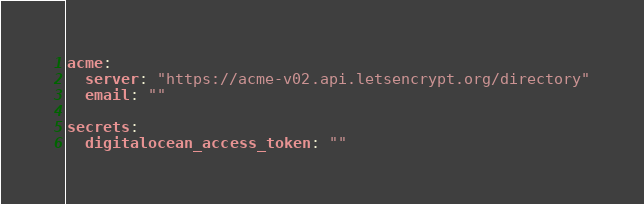Convert code to text. <code><loc_0><loc_0><loc_500><loc_500><_YAML_>acme:
  server: "https://acme-v02.api.letsencrypt.org/directory"
  email: ""

secrets:
  digitalocean_access_token: ""
</code> 